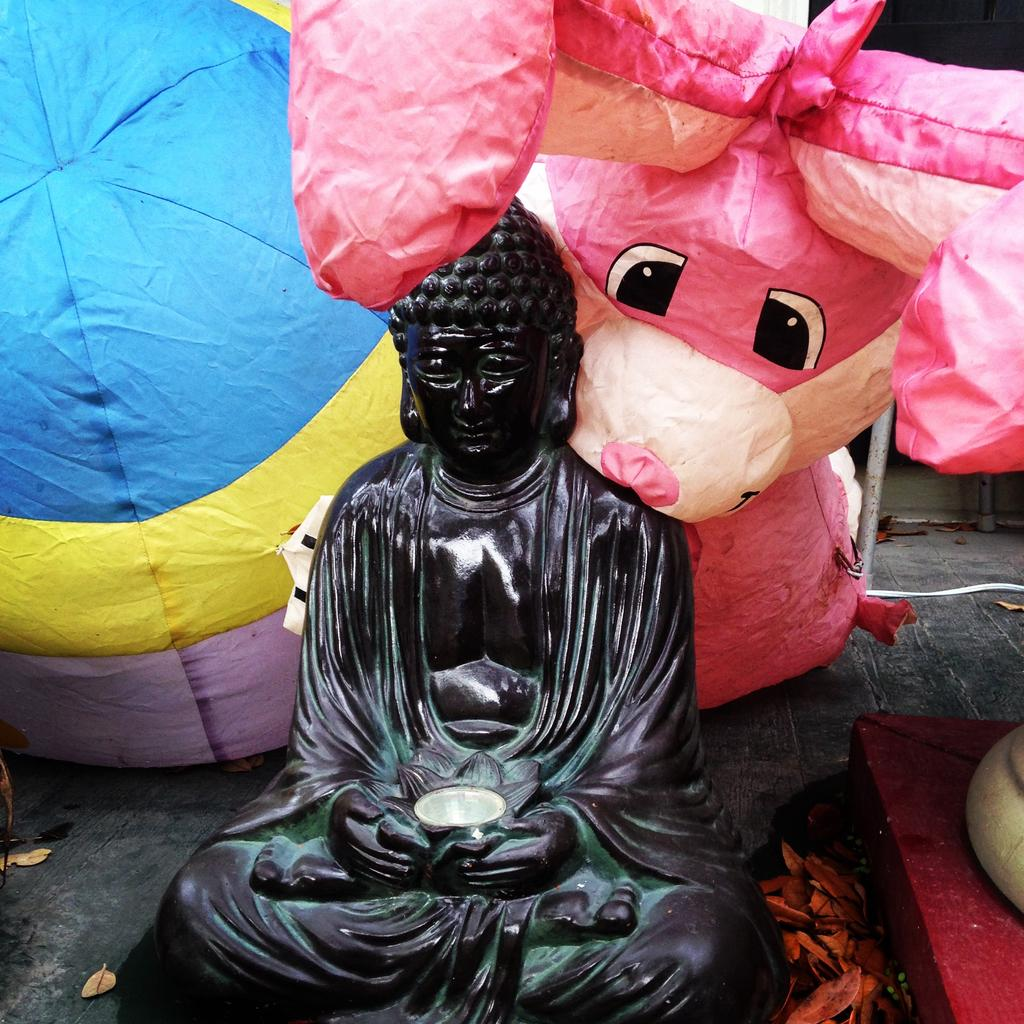What is the main subject in the center of the image? There is a sculpture in the center of the image. What type of toys can be seen in the image? There are balloon toys in the image. What are the rods used for in the image? The purpose of the rods in the image is not specified, but they could be part of the sculpture or used for other purposes. What is the condition of the leaves in the image? Dried leaves are present in the image. What can be seen on the ground in the image? There is a path in the image. What other objects are present on the right side of the image? There are other objects on the right side of the image, but their specific nature is not mentioned in the facts. What type of volleyball game is being played in the image? There is no volleyball game present in the image. What type of wilderness can be seen in the background of the image? The image does not depict a wilderness setting; it contains a sculpture, balloon toys, rods, dried leaves, a path, and other objects. What type of dinner is being served in the image? There is no dinner present in the image. 